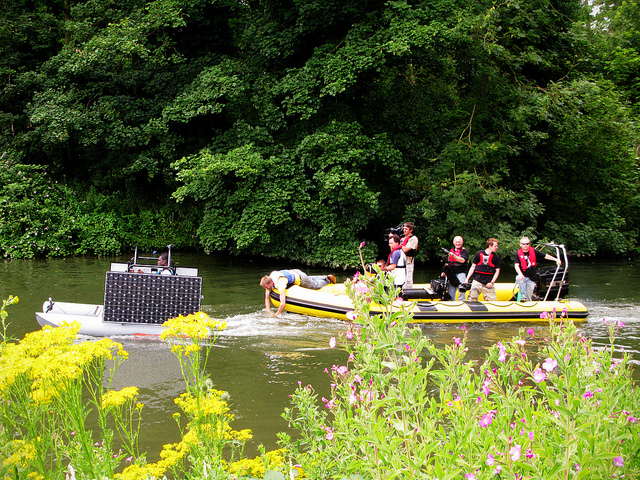Are these boats equipped for safety? Yes, the raft has several individuals wearing life jackets, which indicates basic safety measures are in place for the activity they are participating in. Safety appears to be a priority in this water-based activity. 